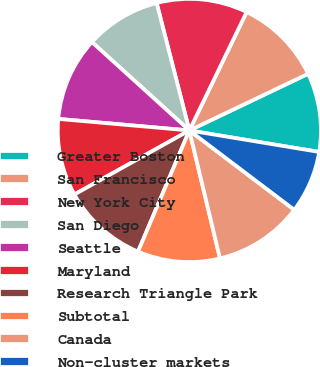Convert chart. <chart><loc_0><loc_0><loc_500><loc_500><pie_chart><fcel>Greater Boston<fcel>San Francisco<fcel>New York City<fcel>San Diego<fcel>Seattle<fcel>Maryland<fcel>Research Triangle Park<fcel>Subtotal<fcel>Canada<fcel>Non-cluster markets<nl><fcel>9.7%<fcel>10.75%<fcel>11.17%<fcel>9.28%<fcel>10.33%<fcel>9.49%<fcel>10.54%<fcel>10.12%<fcel>10.96%<fcel>7.7%<nl></chart> 